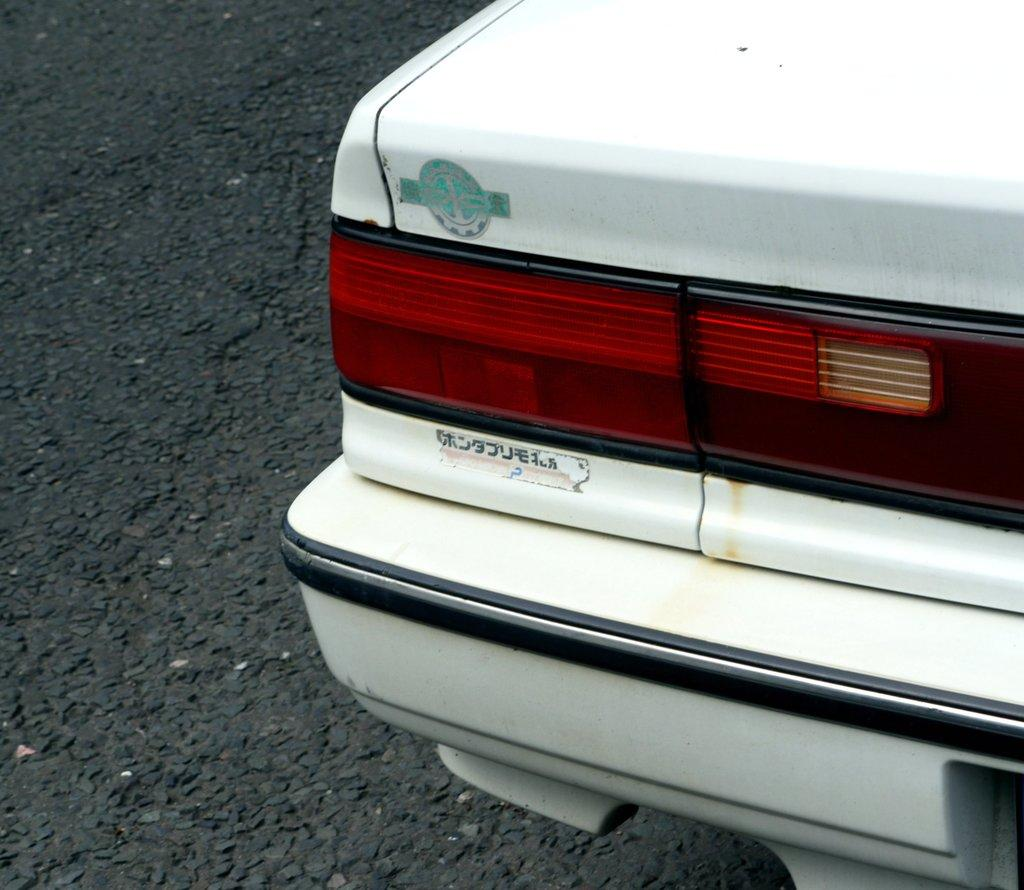What is the main subject of the image? The main subject of the image is a car. Where is the car located in the image? The car is towards the right side of the image. What can be seen on the car? There is text on the car. What is the setting of the image? There is a road in the image, which is towards the left side. Can you see any sea creatures swimming in the image? There is no sea or sea creatures present in the image; it features a car and a road. What type of hat is the town wearing in the image? There is no town or hat present in the image. 